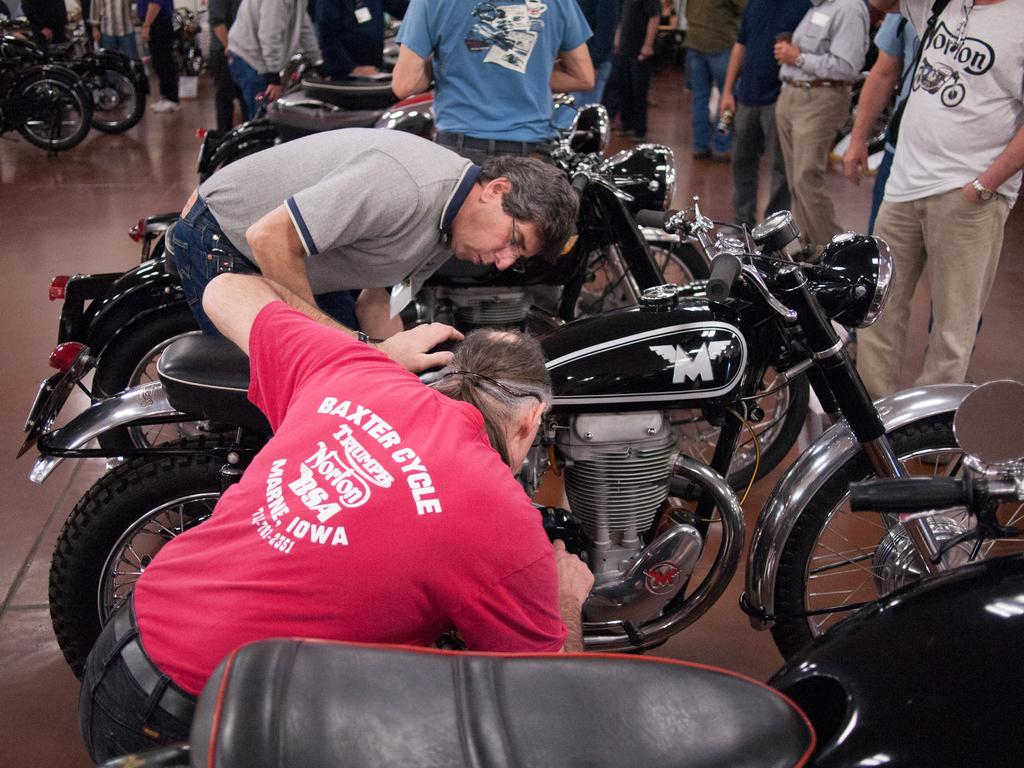What is the main subject of the image? There is a person sitting in the image. What is the person doing in the image? The person is looking at a motorcycle. Are there any other people in the image? Yes, there is a group of people standing in the image. What type of harmony can be heard in the image? There is no sound or music present in the image, so it is not possible to determine what type of harmony might be heard. 